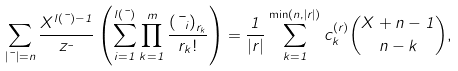Convert formula to latex. <formula><loc_0><loc_0><loc_500><loc_500>\sum _ { | \mu | = n } \frac { X ^ { l ( \mu ) - 1 } } { z _ { \mu } } \left ( \sum _ { i = 1 } ^ { l ( \mu ) } \prod _ { k = 1 } ^ { m } \frac { { ( \mu _ { i } ) } _ { r _ { k } } } { r _ { k } ! } \right ) = \frac { 1 } { | { r } | } \sum _ { k = 1 } ^ { \min ( n , | r | ) } c _ { k } ^ { ( { r } ) } \binom { X + n - 1 } { n - k } ,</formula> 